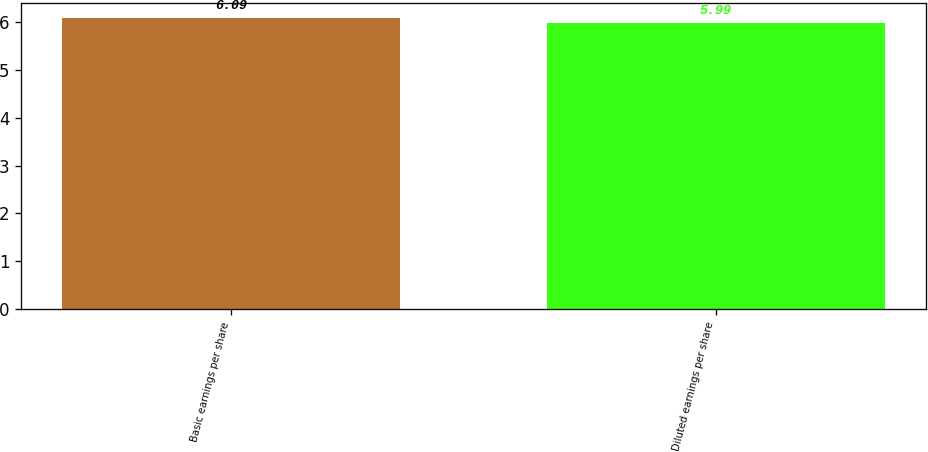<chart> <loc_0><loc_0><loc_500><loc_500><bar_chart><fcel>Basic earnings per share<fcel>Diluted earnings per share<nl><fcel>6.09<fcel>5.99<nl></chart> 